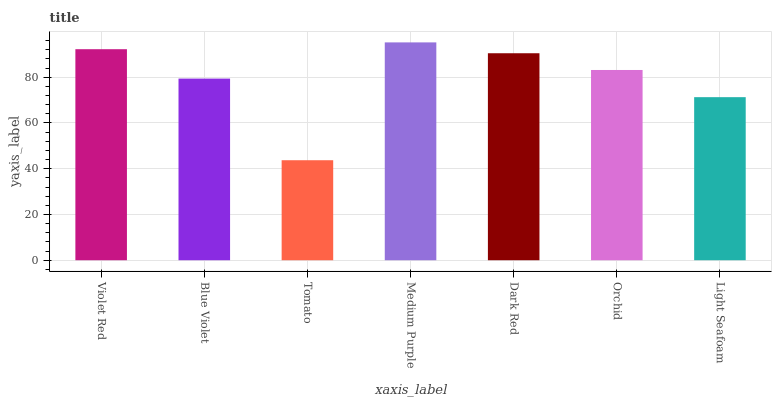Is Blue Violet the minimum?
Answer yes or no. No. Is Blue Violet the maximum?
Answer yes or no. No. Is Violet Red greater than Blue Violet?
Answer yes or no. Yes. Is Blue Violet less than Violet Red?
Answer yes or no. Yes. Is Blue Violet greater than Violet Red?
Answer yes or no. No. Is Violet Red less than Blue Violet?
Answer yes or no. No. Is Orchid the high median?
Answer yes or no. Yes. Is Orchid the low median?
Answer yes or no. Yes. Is Tomato the high median?
Answer yes or no. No. Is Medium Purple the low median?
Answer yes or no. No. 